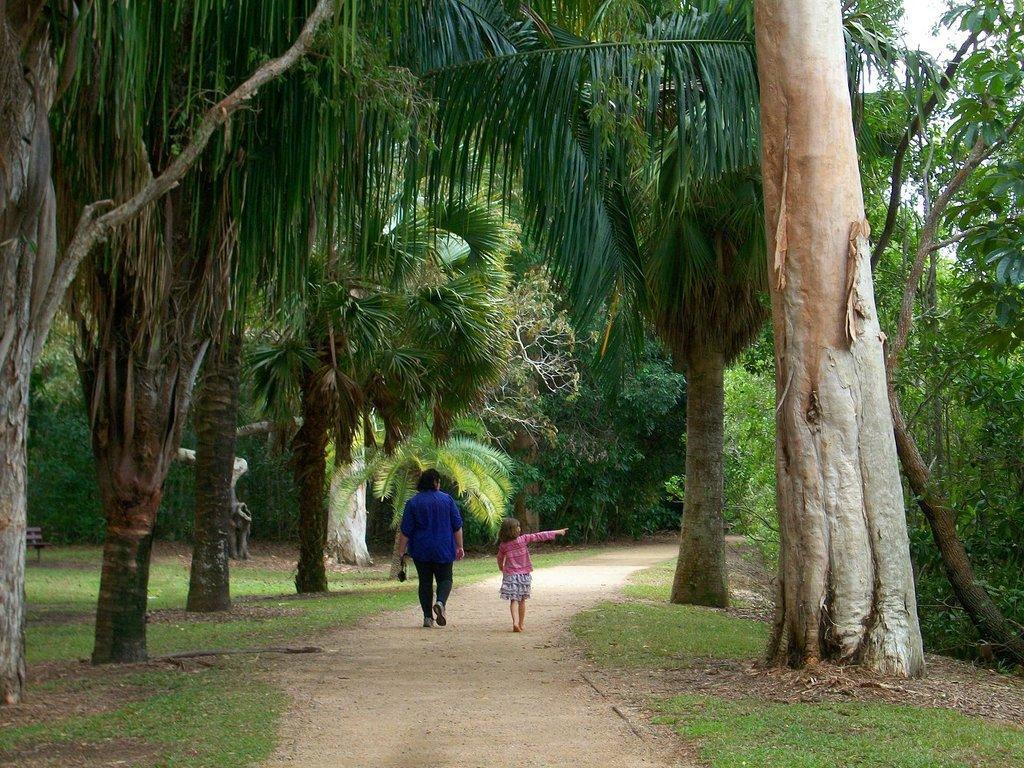Could you give a brief overview of what you see in this image? In this image in the center there are persons walking. In the front on the ground there is grass and in the background there are trees. 